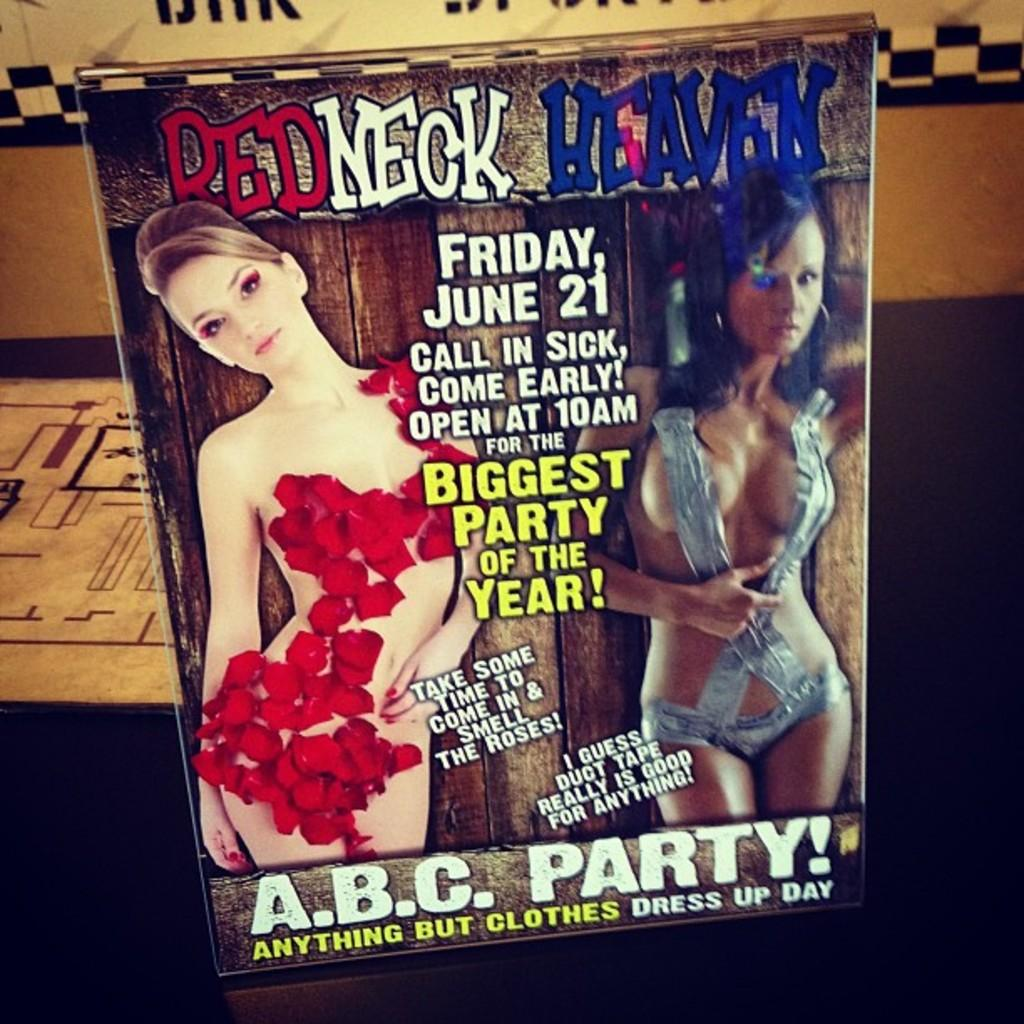What is the main subject of the image? There is an advertisement in the image. What can be seen in the advertisement? The advertisement contains a person. What else is included in the advertisement besides the person? There is text present in the advertisement. How many eggs are visible in the advertisement? There are no eggs visible in the advertisement; it contains a person and text. What type of hospital is featured in the advertisement? There is no hospital present in the advertisement; it is an advertisement with a person and text. 